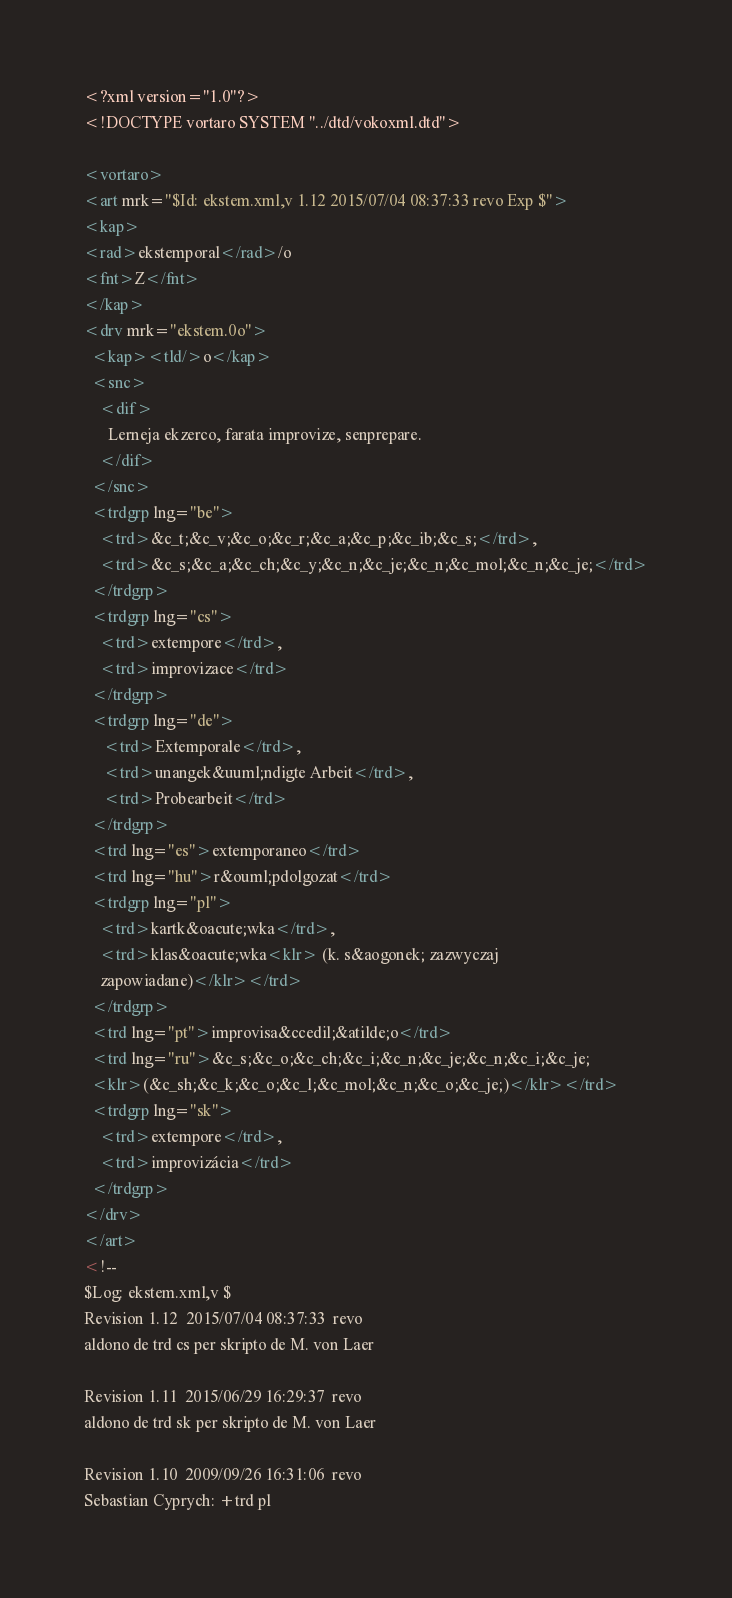Convert code to text. <code><loc_0><loc_0><loc_500><loc_500><_XML_><?xml version="1.0"?>
<!DOCTYPE vortaro SYSTEM "../dtd/vokoxml.dtd">

<vortaro>
<art mrk="$Id: ekstem.xml,v 1.12 2015/07/04 08:37:33 revo Exp $">
<kap>
<rad>ekstemporal</rad>/o
<fnt>Z</fnt>
</kap>
<drv mrk="ekstem.0o">
  <kap><tld/>o</kap>
  <snc>
    <dif>
      Lerneja ekzerco, farata improvize, senprepare.  
    </dif>
  </snc>
  <trdgrp lng="be">
    <trd>&c_t;&c_v;&c_o;&c_r;&c_a;&c_p;&c_ib;&c_s;</trd>,
    <trd>&c_s;&c_a;&c_ch;&c_y;&c_n;&c_je;&c_n;&c_mol;&c_n;&c_je;</trd>
  </trdgrp>
  <trdgrp lng="cs">
    <trd>extempore</trd>,
    <trd>improvizace</trd>
  </trdgrp>
  <trdgrp lng="de">
     <trd>Extemporale</trd>,
     <trd>unangek&uuml;ndigte Arbeit</trd>,
     <trd>Probearbeit</trd>
  </trdgrp>
  <trd lng="es">extemporaneo</trd>
  <trd lng="hu">r&ouml;pdolgozat</trd>
  <trdgrp lng="pl">
    <trd>kartk&oacute;wka</trd>,
    <trd>klas&oacute;wka<klr> (k. s&aogonek; zazwyczaj
    zapowiadane)</klr></trd>
  </trdgrp>
  <trd lng="pt">improvisa&ccedil;&atilde;o</trd>
  <trd lng="ru">&c_s;&c_o;&c_ch;&c_i;&c_n;&c_je;&c_n;&c_i;&c_je;
  <klr>(&c_sh;&c_k;&c_o;&c_l;&c_mol;&c_n;&c_o;&c_je;)</klr></trd>
  <trdgrp lng="sk">
    <trd>extempore</trd>,
    <trd>improvizácia</trd>
  </trdgrp>
</drv>
</art>
<!--
$Log: ekstem.xml,v $
Revision 1.12  2015/07/04 08:37:33  revo
aldono de trd cs per skripto de M. von Laer

Revision 1.11  2015/06/29 16:29:37  revo
aldono de trd sk per skripto de M. von Laer

Revision 1.10  2009/09/26 16:31:06  revo
Sebastian Cyprych: +trd pl
</code> 